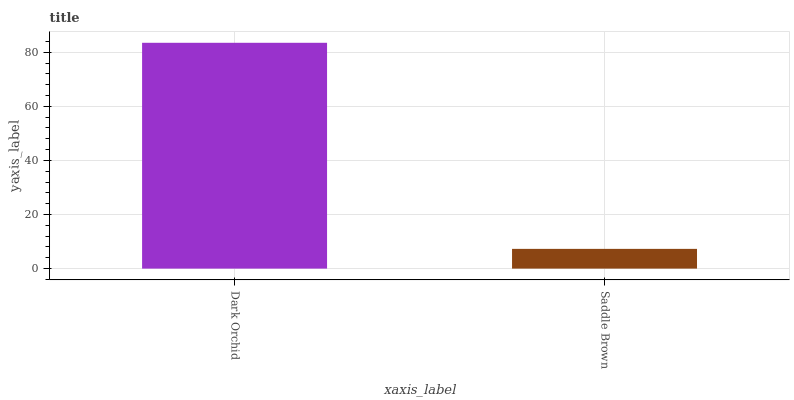Is Saddle Brown the maximum?
Answer yes or no. No. Is Dark Orchid greater than Saddle Brown?
Answer yes or no. Yes. Is Saddle Brown less than Dark Orchid?
Answer yes or no. Yes. Is Saddle Brown greater than Dark Orchid?
Answer yes or no. No. Is Dark Orchid less than Saddle Brown?
Answer yes or no. No. Is Dark Orchid the high median?
Answer yes or no. Yes. Is Saddle Brown the low median?
Answer yes or no. Yes. Is Saddle Brown the high median?
Answer yes or no. No. Is Dark Orchid the low median?
Answer yes or no. No. 